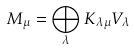<formula> <loc_0><loc_0><loc_500><loc_500>M _ { \mu } = \bigoplus _ { \lambda } K _ { \lambda \mu } V _ { \lambda }</formula> 